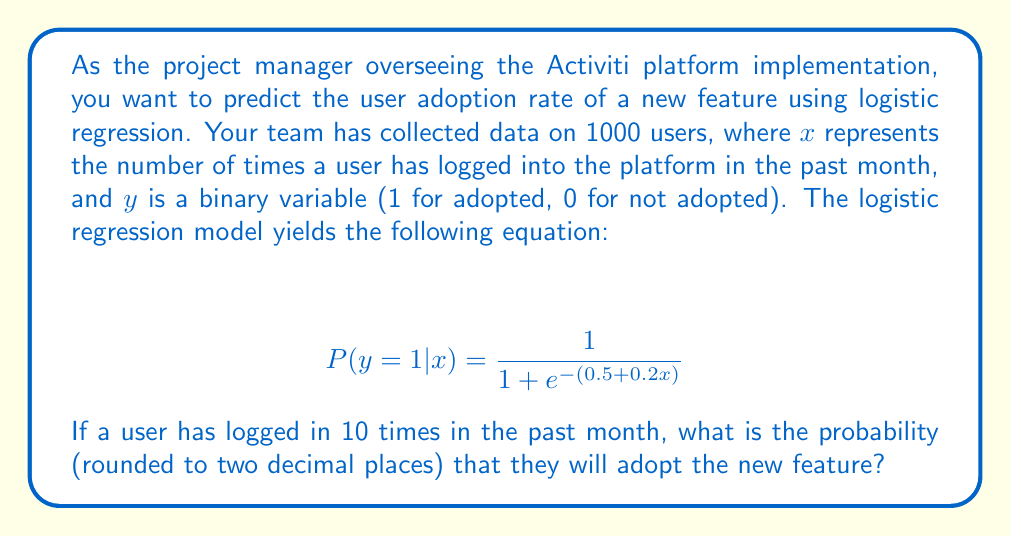Can you solve this math problem? To solve this problem, we'll follow these steps:

1. Understand the logistic regression equation:
   The equation $P(y=1|x) = \frac{1}{1 + e^{-(b_0 + b_1x)}}$ represents the probability of adoption (y=1) given the number of logins (x).
   In this case, $b_0 = 0.5$ and $b_1 = 0.2$.

2. Substitute the given values:
   We know that $x = 10$ (number of logins).

3. Calculate the exponent:
   $-(b_0 + b_1x) = -(0.5 + 0.2 * 10) = -(0.5 + 2) = -2.5$

4. Apply the logistic function:
   $P(y=1|x=10) = \frac{1}{1 + e^{-2.5}}$

5. Calculate the result:
   $P(y=1|x=10) = \frac{1}{1 + e^{-2.5}} \approx 0.9241$

6. Round to two decimal places:
   0.92

This probability indicates a high likelihood of adoption for users who have logged in 10 times in the past month.
Answer: 0.92 